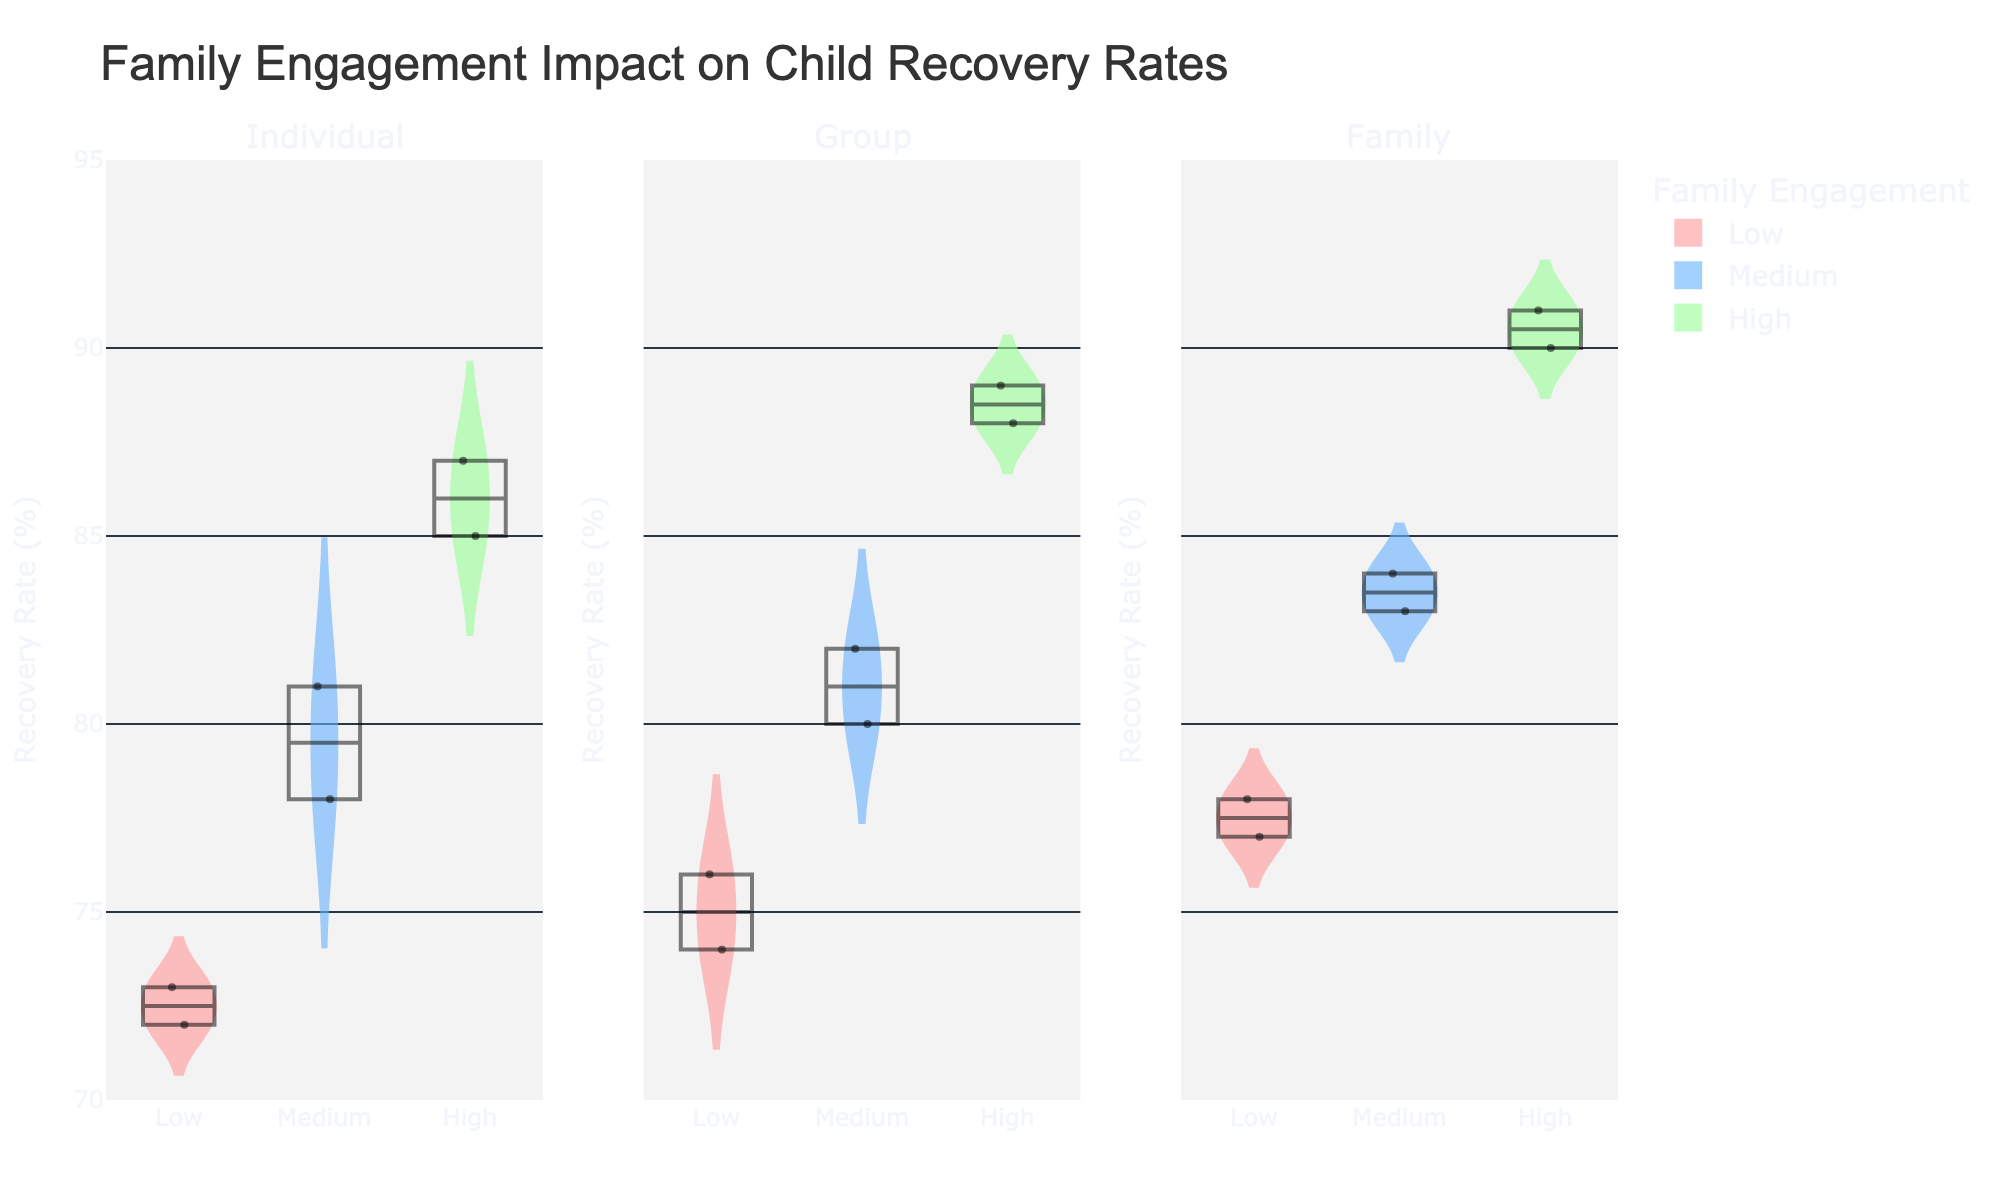What's the title of the figure? The title is usually displayed prominently at the top of the figure. In this case, the title is: "Family Engagement Impact on Child Recovery Rates".
Answer: Family Engagement Impact on Child Recovery Rates How many family engagement levels are shown in the figure? The figure shows three different levels of family engagement, which are represented by distinct colors in the violin plots: Low, Medium, and High.
Answer: Three Which session type has the highest median recovery rate for the 'High' family engagement level? By looking at the median lines in the violin plots, we can see that the Family session type has the highest median recovery rate for the 'High' family engagement level.
Answer: Family What's the median recovery rate for the 'Medium' family engagement level in Individual sessions? To find the median recovery rate, we look at the line in the middle of the box plot within the 'Medium' family engagement violin plot of Individual sessions.
Answer: 80 Which family engagement level shows the widest spread in recovery rates for Group sessions? The width of the violin plot indicates the spread of the data. The 'High' family engagement level for Group sessions shows the widest spread in recovery rates.
Answer: High Compare the highest recovery rates between the three session types for the 'Low' family engagement level. Which session type has the highest recovery rate? By looking at the top of the violin plots for the 'Low' family engagement level, the Family session type has the highest recovery rate.
Answer: Family What is the interquartile range (IQR) for the recovery rates of 'Medium' family engagement in Family sessions? The IQR is the range between the first quartile (Q1) and the third quartile (Q3). Within the box plot overlay on the 'Medium' engagement level for Family sessions, identify Q1 and Q3 and calculate Q3 - Q1.
Answer: 6 (83-77) In which session type does the 'Low' family engagement level have the lowest recovery rate? The bottom end of the violin plot indicates the lowest recovery rate. For 'Low' family engagement, the Individual session type has the lowest recovery rate.
Answer: Individual Is there a session type where the 'High' family engagement level does not overlap with the 'Low' family engagement level in terms of recovery rate? Overlap can be seen where the ranges of the violin plots intersect. In the Family session type, the 'High' family engagement level does not overlap with the 'Low' family engagement level.
Answer: Yes Which family engagement level has the smallest range in recovery rates for Individual sessions? The range of recovery rates is indicated by the height of the violin plot. For Individual sessions, the 'Low' family engagement level has the smallest range.
Answer: Low 